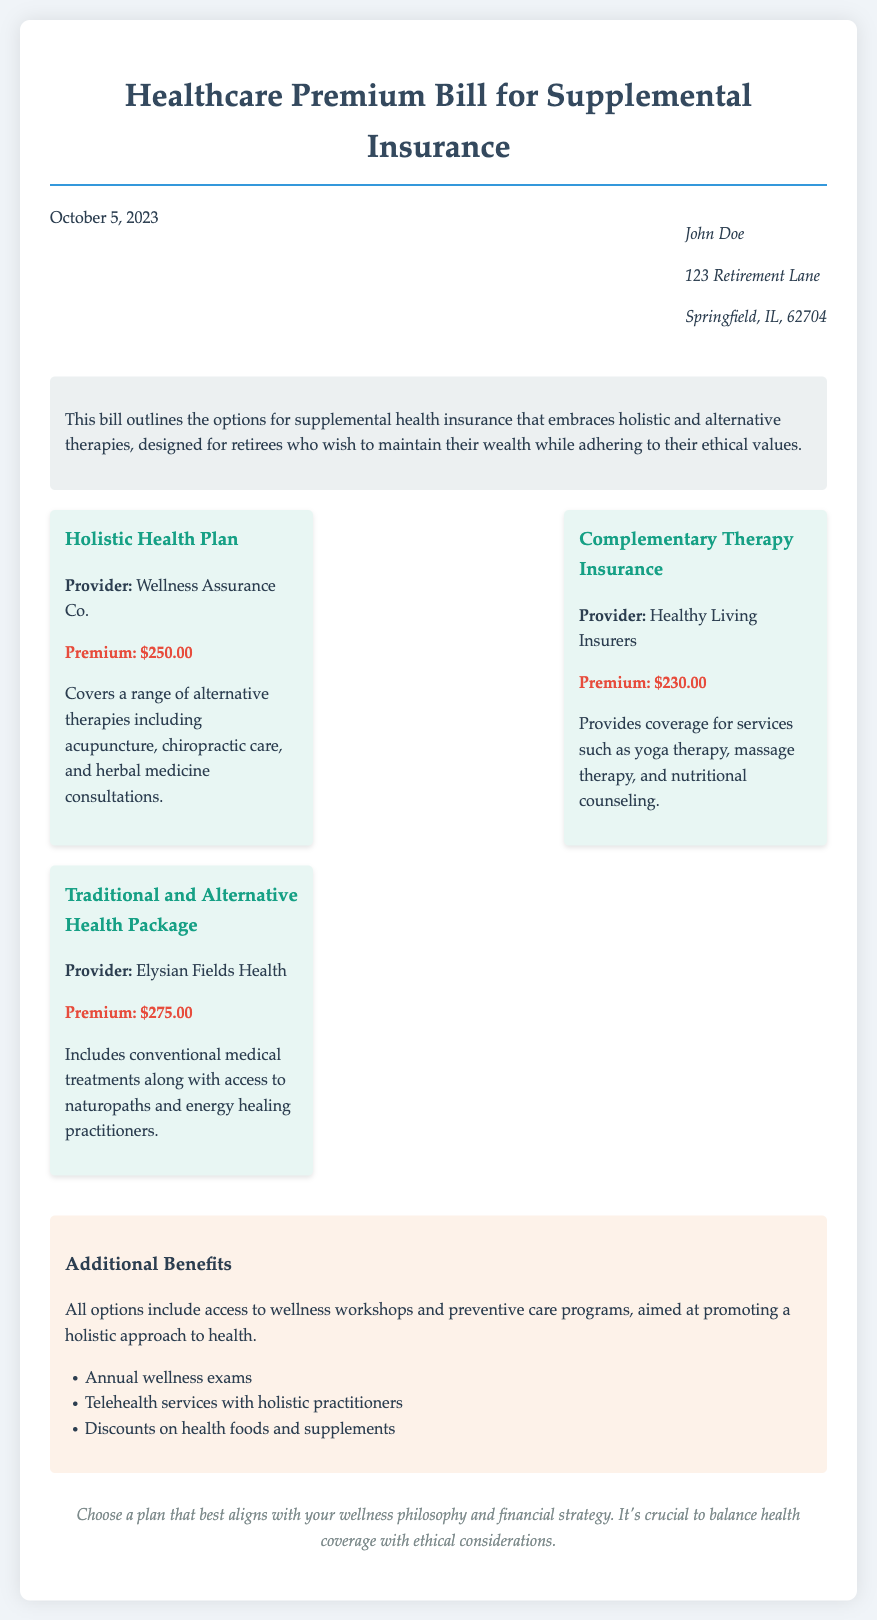What is the date of the bill? The date of the bill is mentioned at the top of the document.
Answer: October 5, 2023 Who is the recipient of the bill? The recipient's name is listed under the date in the header section.
Answer: John Doe What is the premium for the Holistic Health Plan? The premium amount for this plan is specified in the options section.
Answer: $250.00 Which provider offers the Complementary Therapy Insurance? The provider's name is stated under the respective coverage option.
Answer: Healthy Living Insurers What types of therapies does the Holistic Health Plan cover? These therapies are listed in the description of the Holistic Health Plan option.
Answer: Acupuncture, chiropractic care, and herbal medicine consultations What additional benefits do all options include? This information is provided in the additional benefits section of the document.
Answer: Access to wellness workshops and preventive care programs Which plan has the highest premium? The premium amounts for each plan are compared in the options section.
Answer: Traditional and Alternative Health Package What is a key consideration when choosing a plan? This is noted in the conclusion of the document, highlighting a crucial aspect of selection.
Answer: Balance health coverage with ethical considerations 